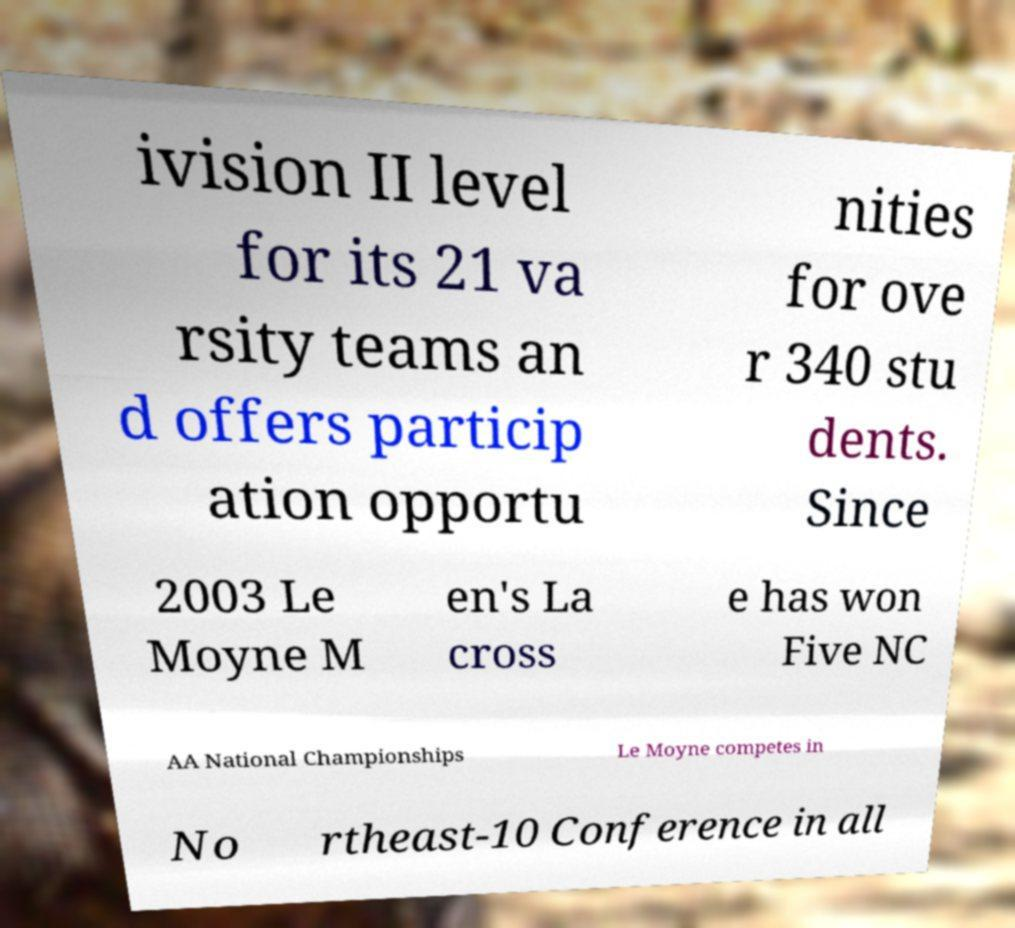Could you assist in decoding the text presented in this image and type it out clearly? ivision II level for its 21 va rsity teams an d offers particip ation opportu nities for ove r 340 stu dents. Since 2003 Le Moyne M en's La cross e has won Five NC AA National Championships Le Moyne competes in No rtheast-10 Conference in all 